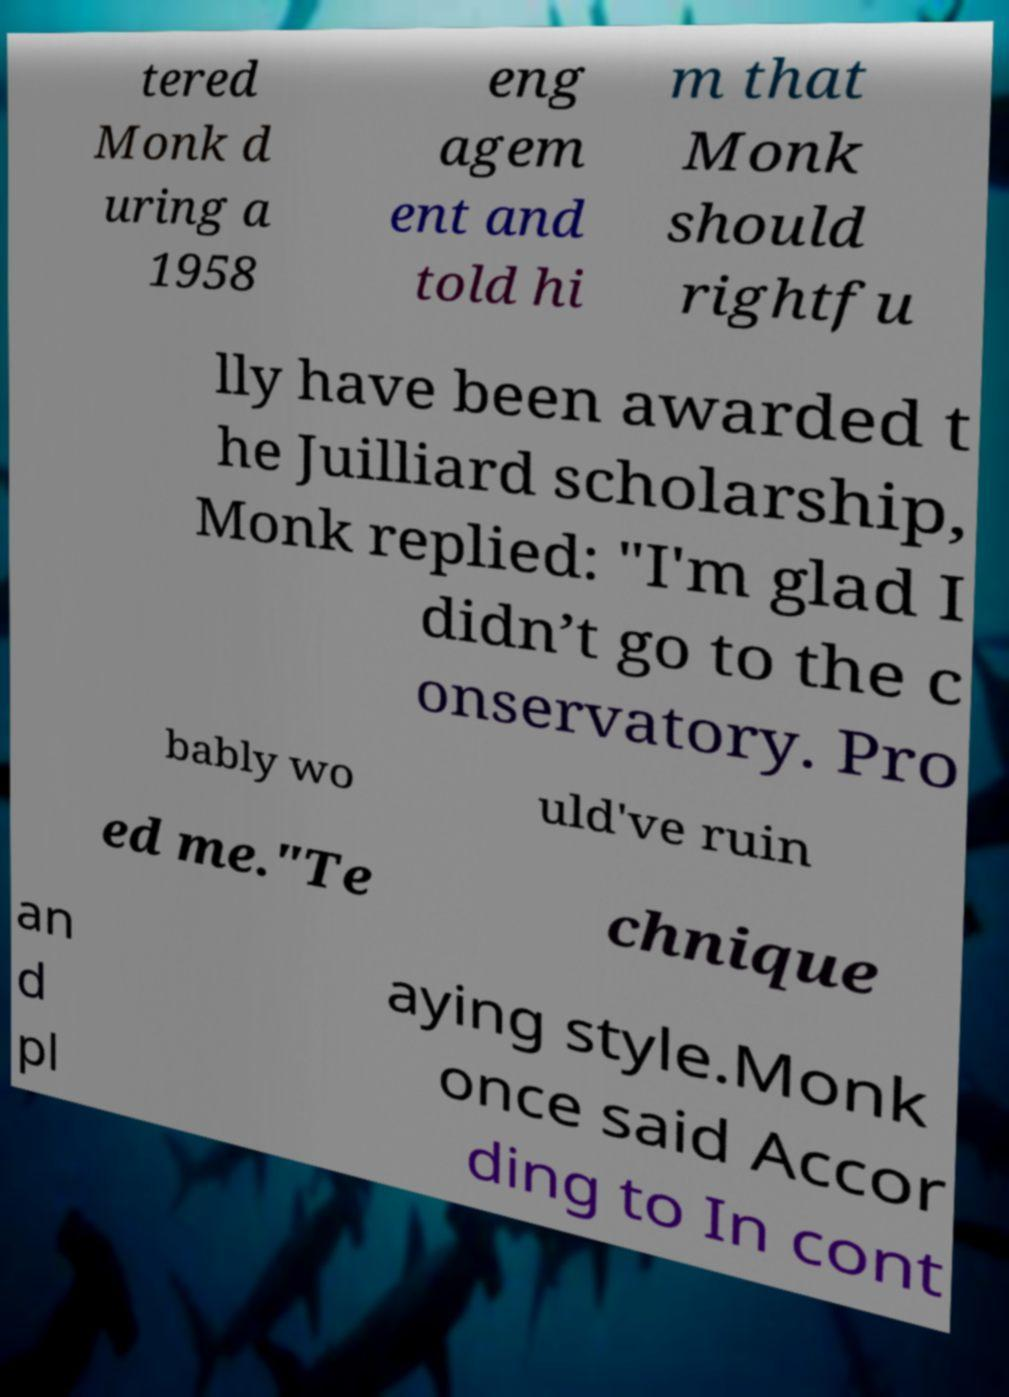Can you accurately transcribe the text from the provided image for me? tered Monk d uring a 1958 eng agem ent and told hi m that Monk should rightfu lly have been awarded t he Juilliard scholarship, Monk replied: "I'm glad I didn’t go to the c onservatory. Pro bably wo uld've ruin ed me."Te chnique an d pl aying style.Monk once said Accor ding to In cont 